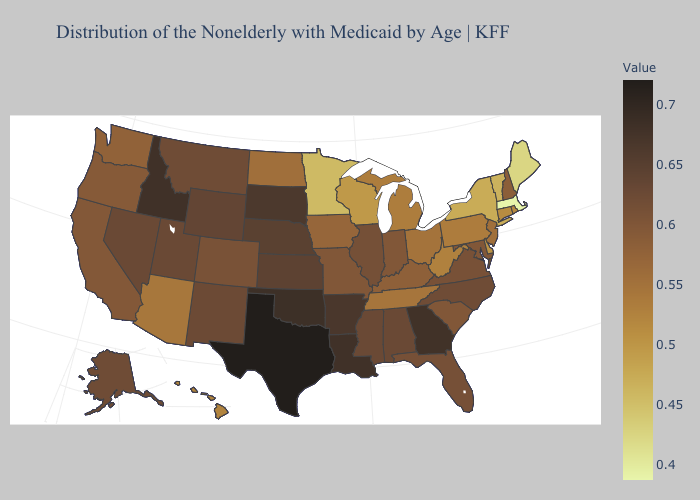Which states hav the highest value in the South?
Short answer required. Texas. Which states have the lowest value in the Northeast?
Answer briefly. Massachusetts. Is the legend a continuous bar?
Be succinct. Yes. Does Utah have the lowest value in the West?
Quick response, please. No. Among the states that border Virginia , does Maryland have the lowest value?
Answer briefly. No. Does Massachusetts have the lowest value in the USA?
Write a very short answer. Yes. 